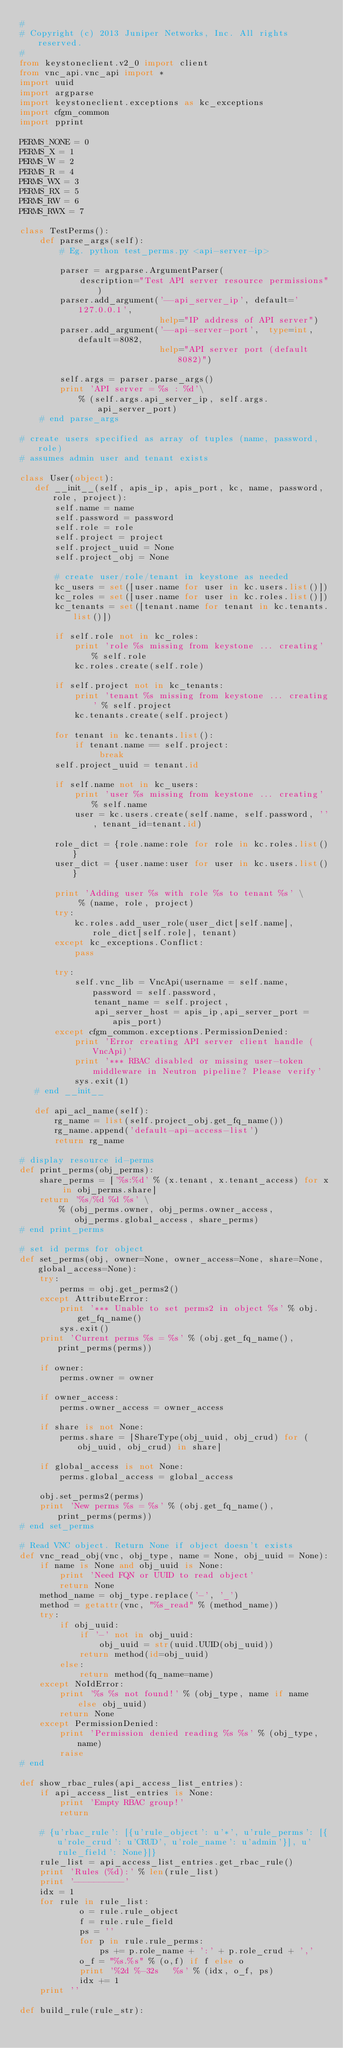Convert code to text. <code><loc_0><loc_0><loc_500><loc_500><_Python_>#
# Copyright (c) 2013 Juniper Networks, Inc. All rights reserved.
#
from keystoneclient.v2_0 import client
from vnc_api.vnc_api import *
import uuid
import argparse
import keystoneclient.exceptions as kc_exceptions
import cfgm_common
import pprint

PERMS_NONE = 0
PERMS_X = 1
PERMS_W = 2
PERMS_R = 4
PERMS_WX = 3
PERMS_RX = 5
PERMS_RW = 6
PERMS_RWX = 7

class TestPerms():
    def parse_args(self):
        # Eg. python test_perms.py <api-server-ip>

        parser = argparse.ArgumentParser(
            description="Test API server resource permissions")
        parser.add_argument('--api_server_ip', default='127.0.0.1',
                            help="IP address of API server")
        parser.add_argument('--api-server-port',  type=int, default=8082,
                            help="API server port (default 8082)")

        self.args = parser.parse_args()
        print 'API server = %s : %d'\
            % (self.args.api_server_ip, self.args.api_server_port)
    # end parse_args

# create users specified as array of tuples (name, password, role)
# assumes admin user and tenant exists

class User(object):
   def __init__(self, apis_ip, apis_port, kc, name, password, role, project):
       self.name = name
       self.password = password
       self.role = role
       self.project = project
       self.project_uuid = None
       self.project_obj = None

       # create user/role/tenant in keystone as needed
       kc_users = set([user.name for user in kc.users.list()])
       kc_roles = set([user.name for user in kc.roles.list()])
       kc_tenants = set([tenant.name for tenant in kc.tenants.list()])

       if self.role not in kc_roles:
           print 'role %s missing from keystone ... creating' % self.role
           kc.roles.create(self.role)

       if self.project not in kc_tenants:
           print 'tenant %s missing from keystone ... creating' % self.project
           kc.tenants.create(self.project)

       for tenant in kc.tenants.list():
           if tenant.name == self.project:
                break
       self.project_uuid = tenant.id
    
       if self.name not in kc_users:
           print 'user %s missing from keystone ... creating' % self.name
           user = kc.users.create(self.name, self.password, '', tenant_id=tenant.id)

       role_dict = {role.name:role for role in kc.roles.list()}
       user_dict = {user.name:user for user in kc.users.list()}

       print 'Adding user %s with role %s to tenant %s' \
            % (name, role, project)
       try:
           kc.roles.add_user_role(user_dict[self.name], role_dict[self.role], tenant)
       except kc_exceptions.Conflict:
           pass

       try:
           self.vnc_lib = VncApi(username = self.name, password = self.password,
               tenant_name = self.project,
               api_server_host = apis_ip,api_server_port = apis_port)
       except cfgm_common.exceptions.PermissionDenied:
           print 'Error creating API server client handle (VncApi)'
           print '*** RBAC disabled or missing user-token middleware in Neutron pipeline? Please verify'
           sys.exit(1)
   # end __init__
    
   def api_acl_name(self):
       rg_name = list(self.project_obj.get_fq_name())
       rg_name.append('default-api-access-list')
       return rg_name

# display resource id-perms
def print_perms(obj_perms):
    share_perms = ['%s:%d' % (x.tenant, x.tenant_access) for x in obj_perms.share]
    return '%s/%d %d %s' \
        % (obj_perms.owner, obj_perms.owner_access,
           obj_perms.global_access, share_perms)
# end print_perms

# set id perms for object
def set_perms(obj, owner=None, owner_access=None, share=None, global_access=None):
    try:
        perms = obj.get_perms2()
    except AttributeError:
        print '*** Unable to set perms2 in object %s' % obj.get_fq_name()
        sys.exit()
    print 'Current perms %s = %s' % (obj.get_fq_name(), print_perms(perms))

    if owner:
        perms.owner = owner

    if owner_access:
        perms.owner_access = owner_access

    if share is not None:
        perms.share = [ShareType(obj_uuid, obj_crud) for (obj_uuid, obj_crud) in share]

    if global_access is not None:
        perms.global_access = global_access

    obj.set_perms2(perms)
    print 'New perms %s = %s' % (obj.get_fq_name(), print_perms(perms))
# end set_perms

# Read VNC object. Return None if object doesn't exists
def vnc_read_obj(vnc, obj_type, name = None, obj_uuid = None):
    if name is None and obj_uuid is None:
        print 'Need FQN or UUID to read object'
        return None
    method_name = obj_type.replace('-', '_')
    method = getattr(vnc, "%s_read" % (method_name))
    try:
        if obj_uuid:
            if '-' not in obj_uuid:
                obj_uuid = str(uuid.UUID(obj_uuid))
            return method(id=obj_uuid)
        else:
            return method(fq_name=name)
    except NoIdError:
        print '%s %s not found!' % (obj_type, name if name else obj_uuid)
        return None
    except PermissionDenied:
        print 'Permission denied reading %s %s' % (obj_type, name)
        raise
# end

def show_rbac_rules(api_access_list_entries):
    if api_access_list_entries is None:
        print 'Empty RBAC group!'
        return

    # {u'rbac_rule': [{u'rule_object': u'*', u'rule_perms': [{u'role_crud': u'CRUD', u'role_name': u'admin'}], u'rule_field': None}]}
    rule_list = api_access_list_entries.get_rbac_rule()
    print 'Rules (%d):' % len(rule_list)
    print '----------'
    idx = 1
    for rule in rule_list:
            o = rule.rule_object
            f = rule.rule_field
            ps = ''
            for p in rule.rule_perms:
                ps += p.role_name + ':' + p.role_crud + ','
            o_f = "%s.%s" % (o,f) if f else o
            print '%2d %-32s   %s' % (idx, o_f, ps)
            idx += 1
    print ''

def build_rule(rule_str):</code> 